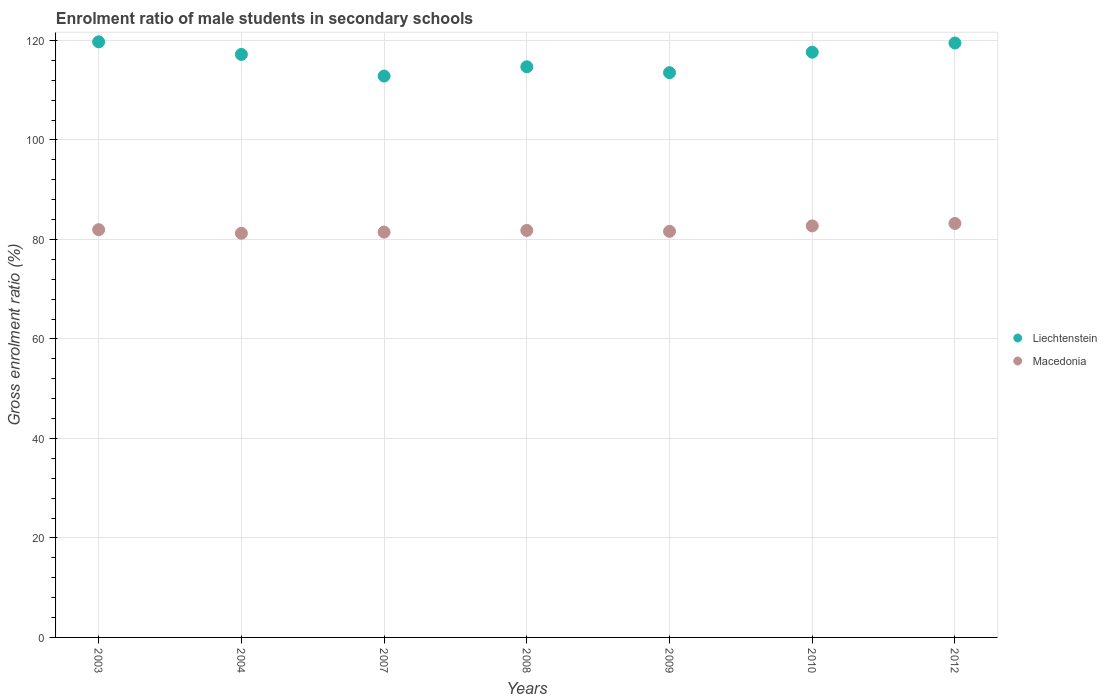What is the enrolment ratio of male students in secondary schools in Macedonia in 2007?
Ensure brevity in your answer.  81.46. Across all years, what is the maximum enrolment ratio of male students in secondary schools in Macedonia?
Provide a succinct answer. 83.21. Across all years, what is the minimum enrolment ratio of male students in secondary schools in Macedonia?
Your answer should be compact. 81.24. In which year was the enrolment ratio of male students in secondary schools in Liechtenstein maximum?
Make the answer very short. 2003. What is the total enrolment ratio of male students in secondary schools in Macedonia in the graph?
Make the answer very short. 574.02. What is the difference between the enrolment ratio of male students in secondary schools in Liechtenstein in 2003 and that in 2004?
Your answer should be compact. 2.53. What is the difference between the enrolment ratio of male students in secondary schools in Macedonia in 2004 and the enrolment ratio of male students in secondary schools in Liechtenstein in 2009?
Offer a very short reply. -32.28. What is the average enrolment ratio of male students in secondary schools in Macedonia per year?
Keep it short and to the point. 82. In the year 2012, what is the difference between the enrolment ratio of male students in secondary schools in Macedonia and enrolment ratio of male students in secondary schools in Liechtenstein?
Provide a short and direct response. -36.27. In how many years, is the enrolment ratio of male students in secondary schools in Liechtenstein greater than 104 %?
Your response must be concise. 7. What is the ratio of the enrolment ratio of male students in secondary schools in Macedonia in 2007 to that in 2010?
Give a very brief answer. 0.98. Is the difference between the enrolment ratio of male students in secondary schools in Macedonia in 2008 and 2010 greater than the difference between the enrolment ratio of male students in secondary schools in Liechtenstein in 2008 and 2010?
Provide a succinct answer. Yes. What is the difference between the highest and the second highest enrolment ratio of male students in secondary schools in Macedonia?
Provide a succinct answer. 0.49. What is the difference between the highest and the lowest enrolment ratio of male students in secondary schools in Macedonia?
Ensure brevity in your answer.  1.97. In how many years, is the enrolment ratio of male students in secondary schools in Macedonia greater than the average enrolment ratio of male students in secondary schools in Macedonia taken over all years?
Ensure brevity in your answer.  2. Is the sum of the enrolment ratio of male students in secondary schools in Macedonia in 2003 and 2009 greater than the maximum enrolment ratio of male students in secondary schools in Liechtenstein across all years?
Your response must be concise. Yes. How many dotlines are there?
Offer a very short reply. 2. What is the difference between two consecutive major ticks on the Y-axis?
Provide a succinct answer. 20. Are the values on the major ticks of Y-axis written in scientific E-notation?
Offer a very short reply. No. Does the graph contain any zero values?
Ensure brevity in your answer.  No. How many legend labels are there?
Make the answer very short. 2. How are the legend labels stacked?
Give a very brief answer. Vertical. What is the title of the graph?
Keep it short and to the point. Enrolment ratio of male students in secondary schools. What is the label or title of the Y-axis?
Your response must be concise. Gross enrolment ratio (%). What is the Gross enrolment ratio (%) of Liechtenstein in 2003?
Your response must be concise. 119.72. What is the Gross enrolment ratio (%) of Macedonia in 2003?
Give a very brief answer. 81.96. What is the Gross enrolment ratio (%) of Liechtenstein in 2004?
Provide a succinct answer. 117.19. What is the Gross enrolment ratio (%) in Macedonia in 2004?
Your answer should be very brief. 81.24. What is the Gross enrolment ratio (%) in Liechtenstein in 2007?
Make the answer very short. 112.84. What is the Gross enrolment ratio (%) of Macedonia in 2007?
Your answer should be very brief. 81.46. What is the Gross enrolment ratio (%) of Liechtenstein in 2008?
Offer a terse response. 114.7. What is the Gross enrolment ratio (%) in Macedonia in 2008?
Your answer should be compact. 81.81. What is the Gross enrolment ratio (%) of Liechtenstein in 2009?
Offer a terse response. 113.52. What is the Gross enrolment ratio (%) in Macedonia in 2009?
Ensure brevity in your answer.  81.62. What is the Gross enrolment ratio (%) of Liechtenstein in 2010?
Ensure brevity in your answer.  117.64. What is the Gross enrolment ratio (%) in Macedonia in 2010?
Make the answer very short. 82.72. What is the Gross enrolment ratio (%) of Liechtenstein in 2012?
Give a very brief answer. 119.48. What is the Gross enrolment ratio (%) of Macedonia in 2012?
Provide a succinct answer. 83.21. Across all years, what is the maximum Gross enrolment ratio (%) of Liechtenstein?
Offer a very short reply. 119.72. Across all years, what is the maximum Gross enrolment ratio (%) of Macedonia?
Give a very brief answer. 83.21. Across all years, what is the minimum Gross enrolment ratio (%) of Liechtenstein?
Offer a very short reply. 112.84. Across all years, what is the minimum Gross enrolment ratio (%) in Macedonia?
Offer a very short reply. 81.24. What is the total Gross enrolment ratio (%) in Liechtenstein in the graph?
Your answer should be compact. 815.08. What is the total Gross enrolment ratio (%) in Macedonia in the graph?
Your answer should be compact. 574.02. What is the difference between the Gross enrolment ratio (%) of Liechtenstein in 2003 and that in 2004?
Keep it short and to the point. 2.53. What is the difference between the Gross enrolment ratio (%) of Macedonia in 2003 and that in 2004?
Provide a short and direct response. 0.72. What is the difference between the Gross enrolment ratio (%) of Liechtenstein in 2003 and that in 2007?
Provide a short and direct response. 6.88. What is the difference between the Gross enrolment ratio (%) in Macedonia in 2003 and that in 2007?
Ensure brevity in your answer.  0.49. What is the difference between the Gross enrolment ratio (%) in Liechtenstein in 2003 and that in 2008?
Offer a terse response. 5.02. What is the difference between the Gross enrolment ratio (%) in Macedonia in 2003 and that in 2008?
Give a very brief answer. 0.15. What is the difference between the Gross enrolment ratio (%) of Liechtenstein in 2003 and that in 2009?
Keep it short and to the point. 6.2. What is the difference between the Gross enrolment ratio (%) of Macedonia in 2003 and that in 2009?
Offer a very short reply. 0.34. What is the difference between the Gross enrolment ratio (%) in Liechtenstein in 2003 and that in 2010?
Offer a terse response. 2.08. What is the difference between the Gross enrolment ratio (%) in Macedonia in 2003 and that in 2010?
Offer a terse response. -0.76. What is the difference between the Gross enrolment ratio (%) of Liechtenstein in 2003 and that in 2012?
Provide a short and direct response. 0.24. What is the difference between the Gross enrolment ratio (%) in Macedonia in 2003 and that in 2012?
Your response must be concise. -1.25. What is the difference between the Gross enrolment ratio (%) in Liechtenstein in 2004 and that in 2007?
Your answer should be very brief. 4.35. What is the difference between the Gross enrolment ratio (%) of Macedonia in 2004 and that in 2007?
Your answer should be compact. -0.22. What is the difference between the Gross enrolment ratio (%) in Liechtenstein in 2004 and that in 2008?
Provide a succinct answer. 2.49. What is the difference between the Gross enrolment ratio (%) in Macedonia in 2004 and that in 2008?
Keep it short and to the point. -0.57. What is the difference between the Gross enrolment ratio (%) in Liechtenstein in 2004 and that in 2009?
Provide a short and direct response. 3.67. What is the difference between the Gross enrolment ratio (%) in Macedonia in 2004 and that in 2009?
Keep it short and to the point. -0.38. What is the difference between the Gross enrolment ratio (%) of Liechtenstein in 2004 and that in 2010?
Offer a terse response. -0.45. What is the difference between the Gross enrolment ratio (%) in Macedonia in 2004 and that in 2010?
Ensure brevity in your answer.  -1.48. What is the difference between the Gross enrolment ratio (%) of Liechtenstein in 2004 and that in 2012?
Make the answer very short. -2.29. What is the difference between the Gross enrolment ratio (%) in Macedonia in 2004 and that in 2012?
Keep it short and to the point. -1.97. What is the difference between the Gross enrolment ratio (%) in Liechtenstein in 2007 and that in 2008?
Your answer should be compact. -1.86. What is the difference between the Gross enrolment ratio (%) in Macedonia in 2007 and that in 2008?
Your answer should be very brief. -0.34. What is the difference between the Gross enrolment ratio (%) in Liechtenstein in 2007 and that in 2009?
Offer a terse response. -0.68. What is the difference between the Gross enrolment ratio (%) in Macedonia in 2007 and that in 2009?
Make the answer very short. -0.16. What is the difference between the Gross enrolment ratio (%) of Liechtenstein in 2007 and that in 2010?
Provide a short and direct response. -4.8. What is the difference between the Gross enrolment ratio (%) in Macedonia in 2007 and that in 2010?
Ensure brevity in your answer.  -1.26. What is the difference between the Gross enrolment ratio (%) in Liechtenstein in 2007 and that in 2012?
Ensure brevity in your answer.  -6.64. What is the difference between the Gross enrolment ratio (%) of Macedonia in 2007 and that in 2012?
Your response must be concise. -1.74. What is the difference between the Gross enrolment ratio (%) in Liechtenstein in 2008 and that in 2009?
Your answer should be very brief. 1.18. What is the difference between the Gross enrolment ratio (%) of Macedonia in 2008 and that in 2009?
Your response must be concise. 0.19. What is the difference between the Gross enrolment ratio (%) of Liechtenstein in 2008 and that in 2010?
Give a very brief answer. -2.93. What is the difference between the Gross enrolment ratio (%) of Macedonia in 2008 and that in 2010?
Make the answer very short. -0.91. What is the difference between the Gross enrolment ratio (%) of Liechtenstein in 2008 and that in 2012?
Ensure brevity in your answer.  -4.78. What is the difference between the Gross enrolment ratio (%) in Macedonia in 2008 and that in 2012?
Provide a short and direct response. -1.4. What is the difference between the Gross enrolment ratio (%) of Liechtenstein in 2009 and that in 2010?
Ensure brevity in your answer.  -4.12. What is the difference between the Gross enrolment ratio (%) in Macedonia in 2009 and that in 2010?
Make the answer very short. -1.1. What is the difference between the Gross enrolment ratio (%) of Liechtenstein in 2009 and that in 2012?
Your answer should be compact. -5.97. What is the difference between the Gross enrolment ratio (%) in Macedonia in 2009 and that in 2012?
Ensure brevity in your answer.  -1.59. What is the difference between the Gross enrolment ratio (%) in Liechtenstein in 2010 and that in 2012?
Provide a short and direct response. -1.85. What is the difference between the Gross enrolment ratio (%) of Macedonia in 2010 and that in 2012?
Make the answer very short. -0.49. What is the difference between the Gross enrolment ratio (%) in Liechtenstein in 2003 and the Gross enrolment ratio (%) in Macedonia in 2004?
Your answer should be compact. 38.48. What is the difference between the Gross enrolment ratio (%) of Liechtenstein in 2003 and the Gross enrolment ratio (%) of Macedonia in 2007?
Offer a terse response. 38.26. What is the difference between the Gross enrolment ratio (%) in Liechtenstein in 2003 and the Gross enrolment ratio (%) in Macedonia in 2008?
Give a very brief answer. 37.91. What is the difference between the Gross enrolment ratio (%) in Liechtenstein in 2003 and the Gross enrolment ratio (%) in Macedonia in 2009?
Provide a short and direct response. 38.1. What is the difference between the Gross enrolment ratio (%) in Liechtenstein in 2003 and the Gross enrolment ratio (%) in Macedonia in 2010?
Provide a succinct answer. 37. What is the difference between the Gross enrolment ratio (%) in Liechtenstein in 2003 and the Gross enrolment ratio (%) in Macedonia in 2012?
Ensure brevity in your answer.  36.51. What is the difference between the Gross enrolment ratio (%) in Liechtenstein in 2004 and the Gross enrolment ratio (%) in Macedonia in 2007?
Ensure brevity in your answer.  35.73. What is the difference between the Gross enrolment ratio (%) in Liechtenstein in 2004 and the Gross enrolment ratio (%) in Macedonia in 2008?
Ensure brevity in your answer.  35.38. What is the difference between the Gross enrolment ratio (%) in Liechtenstein in 2004 and the Gross enrolment ratio (%) in Macedonia in 2009?
Give a very brief answer. 35.57. What is the difference between the Gross enrolment ratio (%) of Liechtenstein in 2004 and the Gross enrolment ratio (%) of Macedonia in 2010?
Provide a short and direct response. 34.47. What is the difference between the Gross enrolment ratio (%) in Liechtenstein in 2004 and the Gross enrolment ratio (%) in Macedonia in 2012?
Offer a very short reply. 33.98. What is the difference between the Gross enrolment ratio (%) of Liechtenstein in 2007 and the Gross enrolment ratio (%) of Macedonia in 2008?
Give a very brief answer. 31.03. What is the difference between the Gross enrolment ratio (%) of Liechtenstein in 2007 and the Gross enrolment ratio (%) of Macedonia in 2009?
Keep it short and to the point. 31.22. What is the difference between the Gross enrolment ratio (%) in Liechtenstein in 2007 and the Gross enrolment ratio (%) in Macedonia in 2010?
Give a very brief answer. 30.12. What is the difference between the Gross enrolment ratio (%) in Liechtenstein in 2007 and the Gross enrolment ratio (%) in Macedonia in 2012?
Make the answer very short. 29.63. What is the difference between the Gross enrolment ratio (%) in Liechtenstein in 2008 and the Gross enrolment ratio (%) in Macedonia in 2009?
Give a very brief answer. 33.08. What is the difference between the Gross enrolment ratio (%) of Liechtenstein in 2008 and the Gross enrolment ratio (%) of Macedonia in 2010?
Provide a succinct answer. 31.98. What is the difference between the Gross enrolment ratio (%) in Liechtenstein in 2008 and the Gross enrolment ratio (%) in Macedonia in 2012?
Your answer should be compact. 31.49. What is the difference between the Gross enrolment ratio (%) in Liechtenstein in 2009 and the Gross enrolment ratio (%) in Macedonia in 2010?
Make the answer very short. 30.8. What is the difference between the Gross enrolment ratio (%) in Liechtenstein in 2009 and the Gross enrolment ratio (%) in Macedonia in 2012?
Your response must be concise. 30.31. What is the difference between the Gross enrolment ratio (%) in Liechtenstein in 2010 and the Gross enrolment ratio (%) in Macedonia in 2012?
Offer a terse response. 34.43. What is the average Gross enrolment ratio (%) in Liechtenstein per year?
Provide a succinct answer. 116.44. What is the average Gross enrolment ratio (%) in Macedonia per year?
Offer a terse response. 82. In the year 2003, what is the difference between the Gross enrolment ratio (%) in Liechtenstein and Gross enrolment ratio (%) in Macedonia?
Provide a succinct answer. 37.76. In the year 2004, what is the difference between the Gross enrolment ratio (%) in Liechtenstein and Gross enrolment ratio (%) in Macedonia?
Offer a terse response. 35.95. In the year 2007, what is the difference between the Gross enrolment ratio (%) of Liechtenstein and Gross enrolment ratio (%) of Macedonia?
Give a very brief answer. 31.37. In the year 2008, what is the difference between the Gross enrolment ratio (%) of Liechtenstein and Gross enrolment ratio (%) of Macedonia?
Give a very brief answer. 32.89. In the year 2009, what is the difference between the Gross enrolment ratio (%) in Liechtenstein and Gross enrolment ratio (%) in Macedonia?
Offer a very short reply. 31.89. In the year 2010, what is the difference between the Gross enrolment ratio (%) in Liechtenstein and Gross enrolment ratio (%) in Macedonia?
Provide a short and direct response. 34.92. In the year 2012, what is the difference between the Gross enrolment ratio (%) in Liechtenstein and Gross enrolment ratio (%) in Macedonia?
Ensure brevity in your answer.  36.27. What is the ratio of the Gross enrolment ratio (%) in Liechtenstein in 2003 to that in 2004?
Your response must be concise. 1.02. What is the ratio of the Gross enrolment ratio (%) in Macedonia in 2003 to that in 2004?
Offer a terse response. 1.01. What is the ratio of the Gross enrolment ratio (%) in Liechtenstein in 2003 to that in 2007?
Give a very brief answer. 1.06. What is the ratio of the Gross enrolment ratio (%) in Macedonia in 2003 to that in 2007?
Your answer should be compact. 1.01. What is the ratio of the Gross enrolment ratio (%) in Liechtenstein in 2003 to that in 2008?
Your response must be concise. 1.04. What is the ratio of the Gross enrolment ratio (%) of Macedonia in 2003 to that in 2008?
Ensure brevity in your answer.  1. What is the ratio of the Gross enrolment ratio (%) of Liechtenstein in 2003 to that in 2009?
Your answer should be very brief. 1.05. What is the ratio of the Gross enrolment ratio (%) of Liechtenstein in 2003 to that in 2010?
Ensure brevity in your answer.  1.02. What is the ratio of the Gross enrolment ratio (%) of Liechtenstein in 2003 to that in 2012?
Offer a very short reply. 1. What is the ratio of the Gross enrolment ratio (%) of Liechtenstein in 2004 to that in 2007?
Provide a succinct answer. 1.04. What is the ratio of the Gross enrolment ratio (%) in Liechtenstein in 2004 to that in 2008?
Your answer should be compact. 1.02. What is the ratio of the Gross enrolment ratio (%) in Macedonia in 2004 to that in 2008?
Offer a very short reply. 0.99. What is the ratio of the Gross enrolment ratio (%) in Liechtenstein in 2004 to that in 2009?
Make the answer very short. 1.03. What is the ratio of the Gross enrolment ratio (%) of Liechtenstein in 2004 to that in 2010?
Your response must be concise. 1. What is the ratio of the Gross enrolment ratio (%) in Macedonia in 2004 to that in 2010?
Your response must be concise. 0.98. What is the ratio of the Gross enrolment ratio (%) in Liechtenstein in 2004 to that in 2012?
Offer a very short reply. 0.98. What is the ratio of the Gross enrolment ratio (%) in Macedonia in 2004 to that in 2012?
Give a very brief answer. 0.98. What is the ratio of the Gross enrolment ratio (%) of Liechtenstein in 2007 to that in 2008?
Provide a short and direct response. 0.98. What is the ratio of the Gross enrolment ratio (%) in Macedonia in 2007 to that in 2008?
Keep it short and to the point. 1. What is the ratio of the Gross enrolment ratio (%) in Liechtenstein in 2007 to that in 2009?
Your answer should be compact. 0.99. What is the ratio of the Gross enrolment ratio (%) in Liechtenstein in 2007 to that in 2010?
Your answer should be compact. 0.96. What is the ratio of the Gross enrolment ratio (%) in Liechtenstein in 2008 to that in 2009?
Provide a short and direct response. 1.01. What is the ratio of the Gross enrolment ratio (%) in Liechtenstein in 2008 to that in 2010?
Your answer should be very brief. 0.98. What is the ratio of the Gross enrolment ratio (%) of Liechtenstein in 2008 to that in 2012?
Give a very brief answer. 0.96. What is the ratio of the Gross enrolment ratio (%) of Macedonia in 2008 to that in 2012?
Your response must be concise. 0.98. What is the ratio of the Gross enrolment ratio (%) of Liechtenstein in 2009 to that in 2010?
Keep it short and to the point. 0.96. What is the ratio of the Gross enrolment ratio (%) in Macedonia in 2009 to that in 2010?
Provide a short and direct response. 0.99. What is the ratio of the Gross enrolment ratio (%) in Liechtenstein in 2009 to that in 2012?
Your answer should be compact. 0.95. What is the ratio of the Gross enrolment ratio (%) of Macedonia in 2009 to that in 2012?
Your answer should be very brief. 0.98. What is the ratio of the Gross enrolment ratio (%) in Liechtenstein in 2010 to that in 2012?
Your response must be concise. 0.98. What is the ratio of the Gross enrolment ratio (%) in Macedonia in 2010 to that in 2012?
Make the answer very short. 0.99. What is the difference between the highest and the second highest Gross enrolment ratio (%) of Liechtenstein?
Your answer should be compact. 0.24. What is the difference between the highest and the second highest Gross enrolment ratio (%) of Macedonia?
Ensure brevity in your answer.  0.49. What is the difference between the highest and the lowest Gross enrolment ratio (%) of Liechtenstein?
Give a very brief answer. 6.88. What is the difference between the highest and the lowest Gross enrolment ratio (%) of Macedonia?
Your response must be concise. 1.97. 